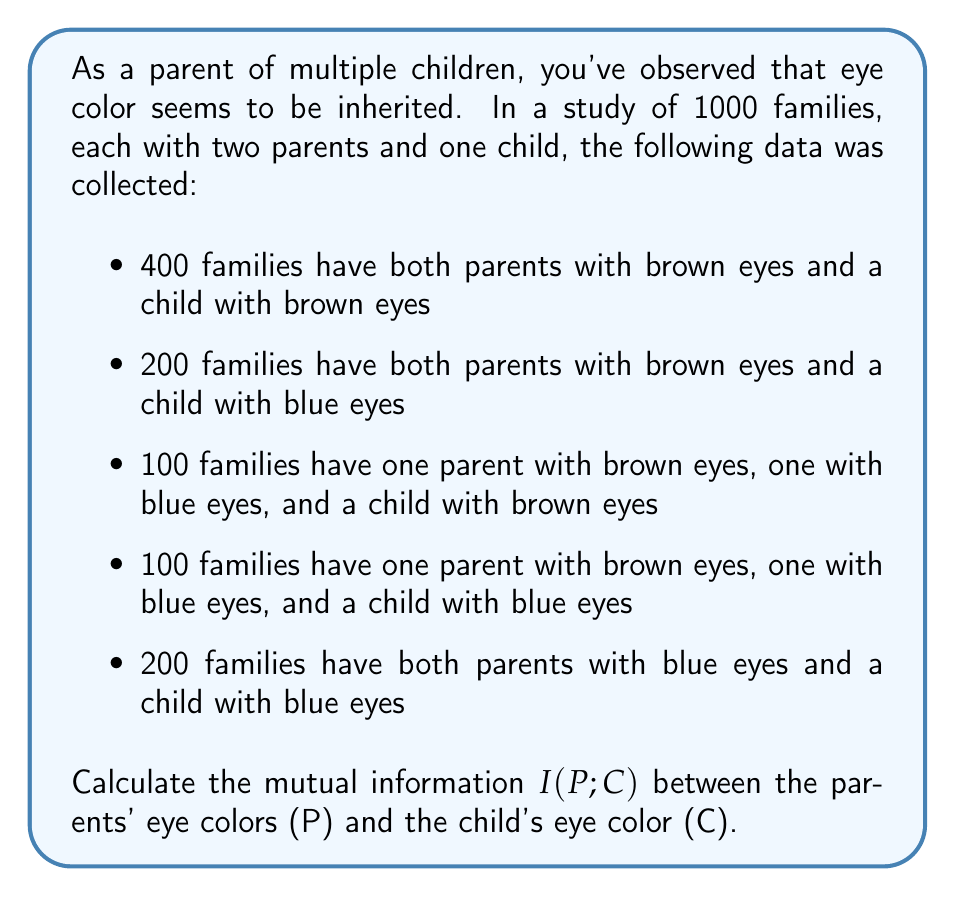Can you solve this math problem? To calculate the mutual information, we'll follow these steps:

1) First, let's calculate the probabilities:

   $P(P_{bb}) = 0.6$, $P(P_{bB}) = 0.2$, $P(P_{BB}) = 0.2$
   $P(C_b) = 0.6$, $P(C_B) = 0.4$
   
   $P(P_{bb}, C_b) = 0.4$, $P(P_{bb}, C_B) = 0.2$
   $P(P_{bB}, C_b) = 0.1$, $P(P_{bB}, C_B) = 0.1$
   $P(P_{BB}, C_b) = 0$, $P(P_{BB}, C_B) = 0.2$

   Where b stands for brown and B for blue.

2) The mutual information is given by:

   $$I(P;C) = \sum_{p,c} P(p,c) \log_2 \frac{P(p,c)}{P(p)P(c)}$$

3) Let's calculate each term:

   $0.4 \log_2 \frac{0.4}{0.6 \cdot 0.6} = 0.4 \log_2 1.11 = 0.152$
   $0.2 \log_2 \frac{0.2}{0.6 \cdot 0.4} = 0.2 \log_2 0.83 = -0.047$
   $0.1 \log_2 \frac{0.1}{0.2 \cdot 0.6} = 0.1 \log_2 0.83 = -0.024$
   $0.1 \log_2 \frac{0.1}{0.2 \cdot 0.4} = 0.1 \log_2 1.25 = 0.032$
   $0 \log_2 \frac{0}{0.2 \cdot 0.6} = 0$ (by convention, $0 \log 0 = 0$)
   $0.2 \log_2 \frac{0.2}{0.2 \cdot 0.4} = 0.2 \log_2 2.5 = 0.321$

4) Sum all these terms:

   $I(P;C) = 0.152 - 0.047 - 0.024 + 0.032 + 0 + 0.321 = 0.434$

Thus, the mutual information between parents' and child's eye color is 0.434 bits.
Answer: $I(P;C) = 0.434$ bits 